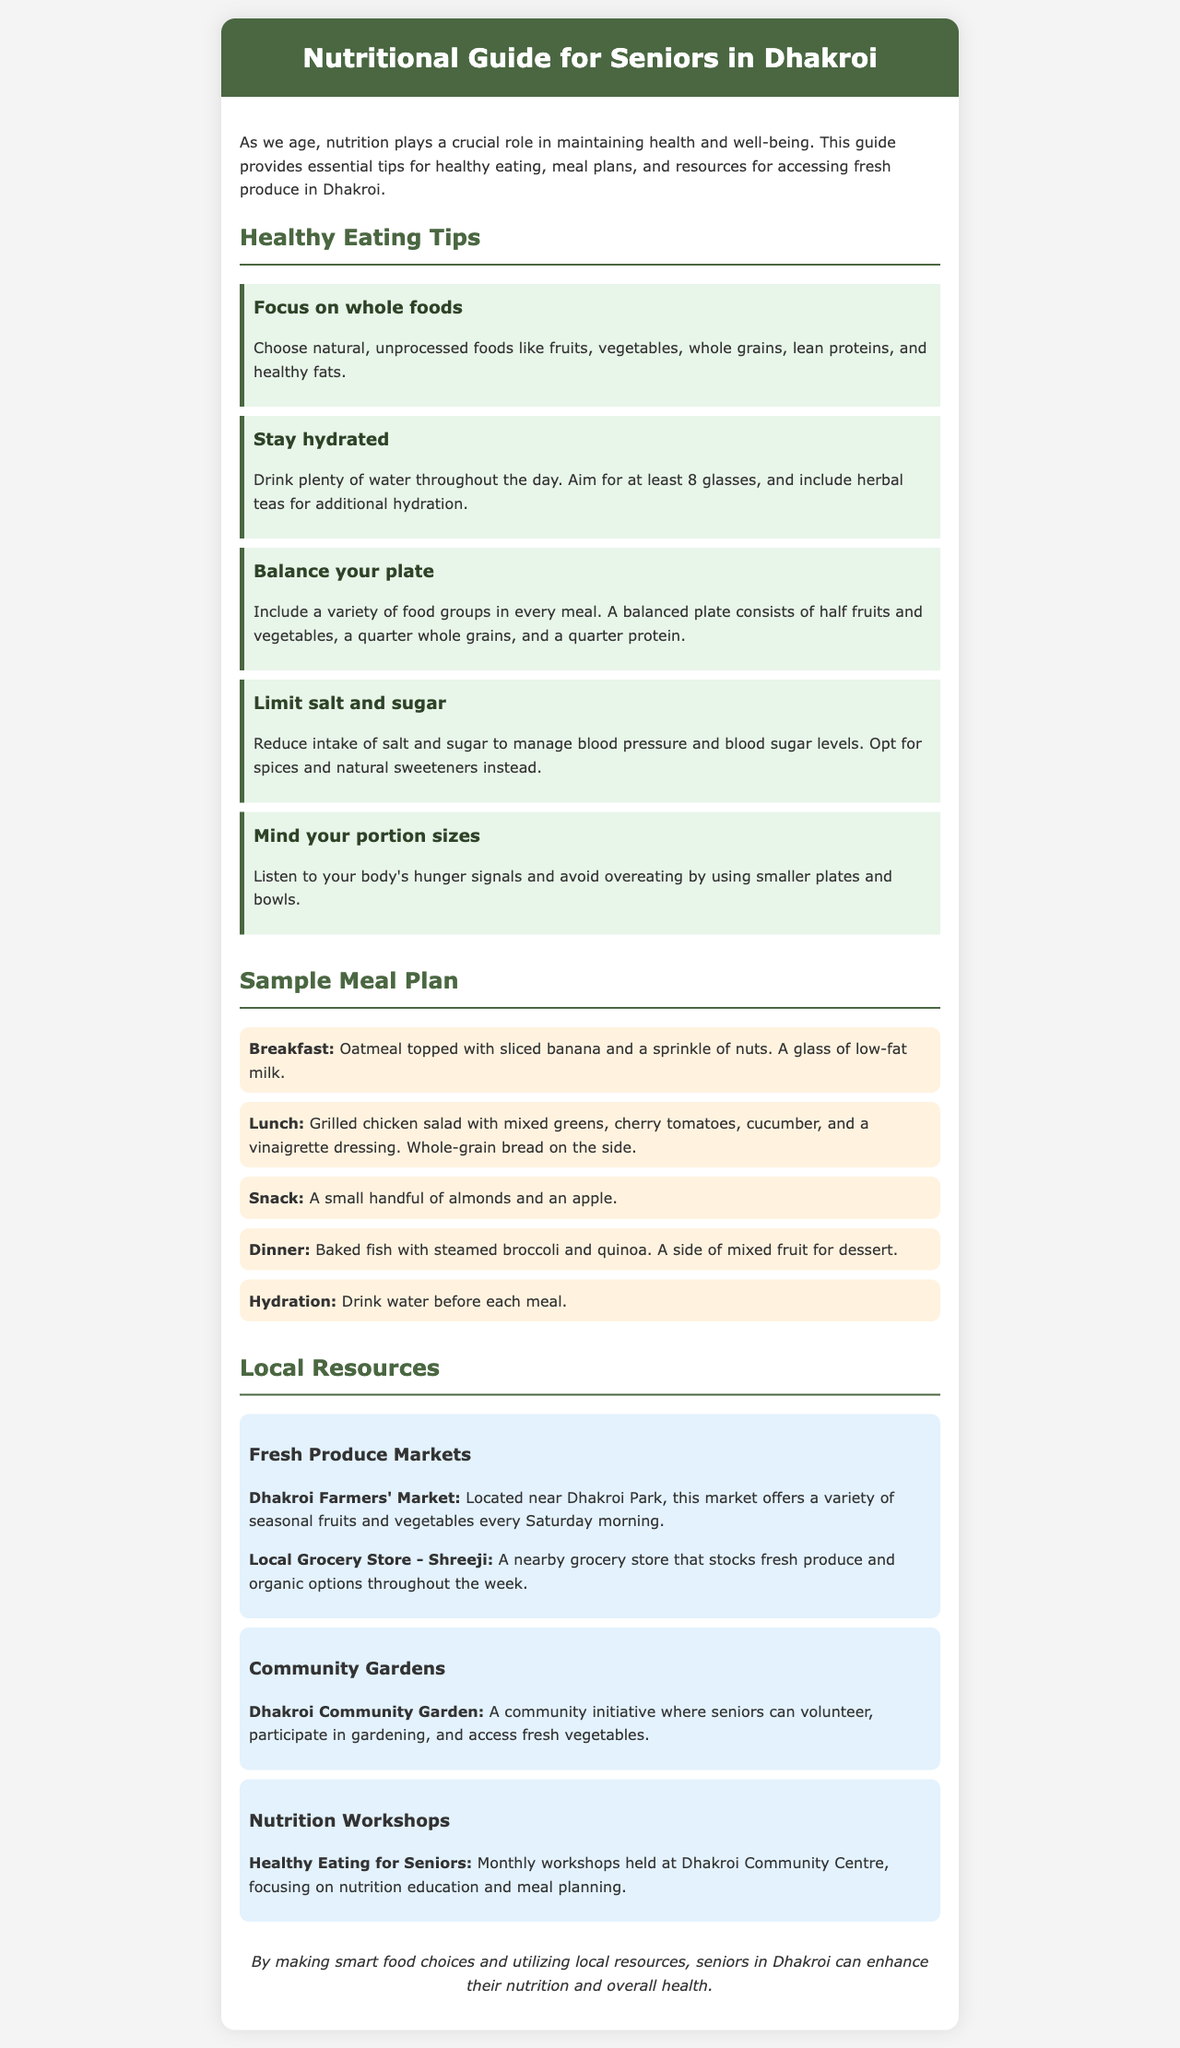what is the title of the brochure? The title is stated at the top of the document in the header section.
Answer: Nutritional Guide for Seniors in Dhakroi how many tips for healthy eating are provided? The document lists five specific tips in the healthy eating tips section.
Answer: 5 what is included in the sample breakfast? The breakfast section details the specific items recommended for the meal.
Answer: Oatmeal topped with sliced banana and a sprinkle of nuts. A glass of low-fat milk where is the Dhakroi Farmers' Market located? The document provides the location of the market near Dhakroi Park.
Answer: near Dhakroi Park what is the purpose of the Healthy Eating for Seniors workshops? The document outlines the focus of the workshops held at the community center.
Answer: nutrition education and meal planning what type of food should seniors focus on? The document emphasizes the importance of a certain type of food for health.
Answer: whole foods what is a suggested alternative to manage blood pressure and blood sugar levels? The document mentions how to manage these health metrics through dietary choices.
Answer: spices and natural sweeteners 